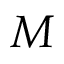<formula> <loc_0><loc_0><loc_500><loc_500>M</formula> 